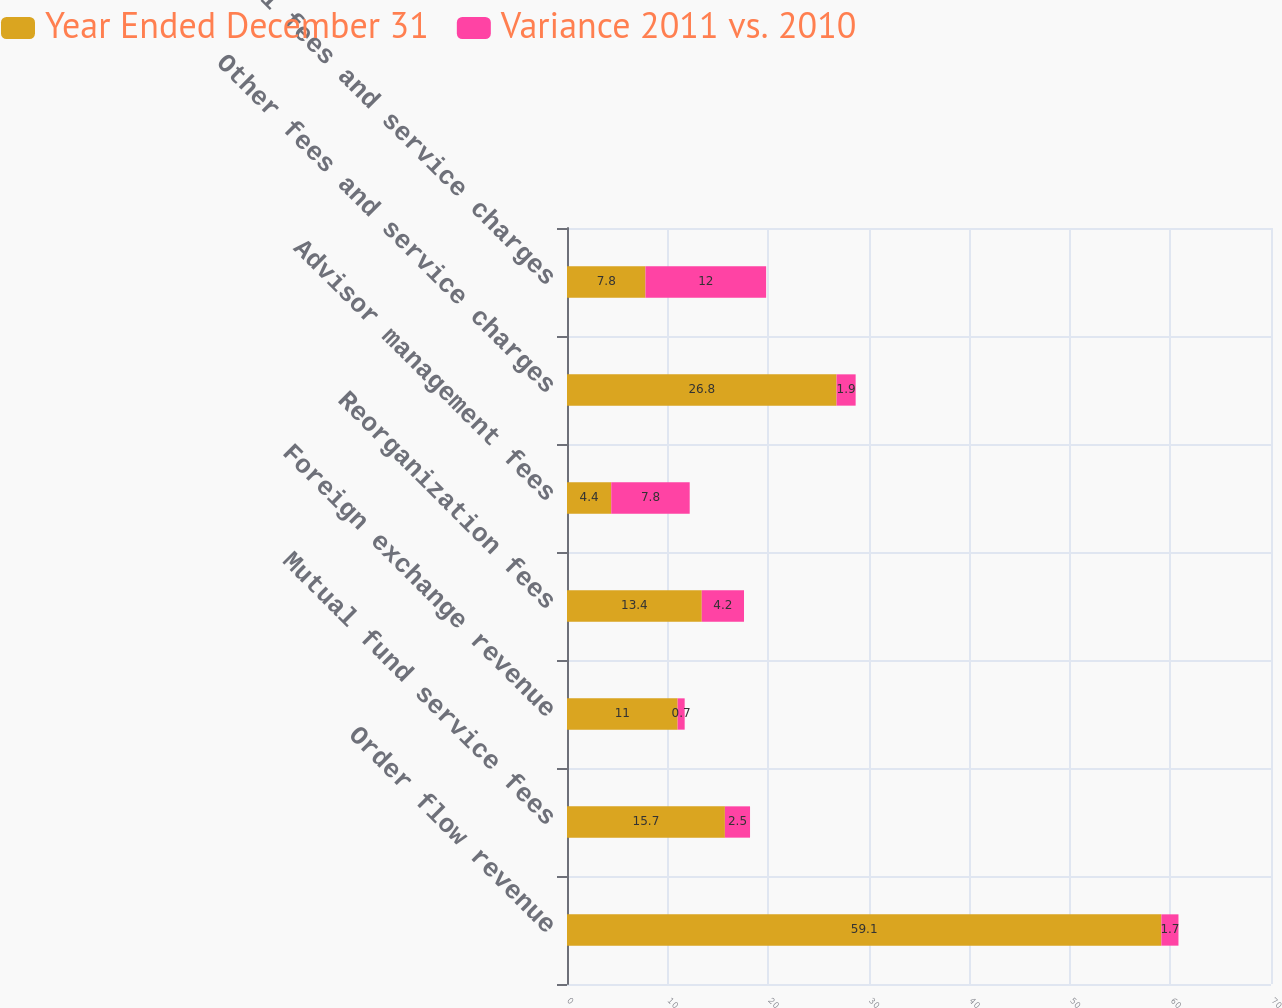Convert chart. <chart><loc_0><loc_0><loc_500><loc_500><stacked_bar_chart><ecel><fcel>Order flow revenue<fcel>Mutual fund service fees<fcel>Foreign exchange revenue<fcel>Reorganization fees<fcel>Advisor management fees<fcel>Other fees and service charges<fcel>Total fees and service charges<nl><fcel>Year Ended December 31<fcel>59.1<fcel>15.7<fcel>11<fcel>13.4<fcel>4.4<fcel>26.8<fcel>7.8<nl><fcel>Variance 2011 vs. 2010<fcel>1.7<fcel>2.5<fcel>0.7<fcel>4.2<fcel>7.8<fcel>1.9<fcel>12<nl></chart> 